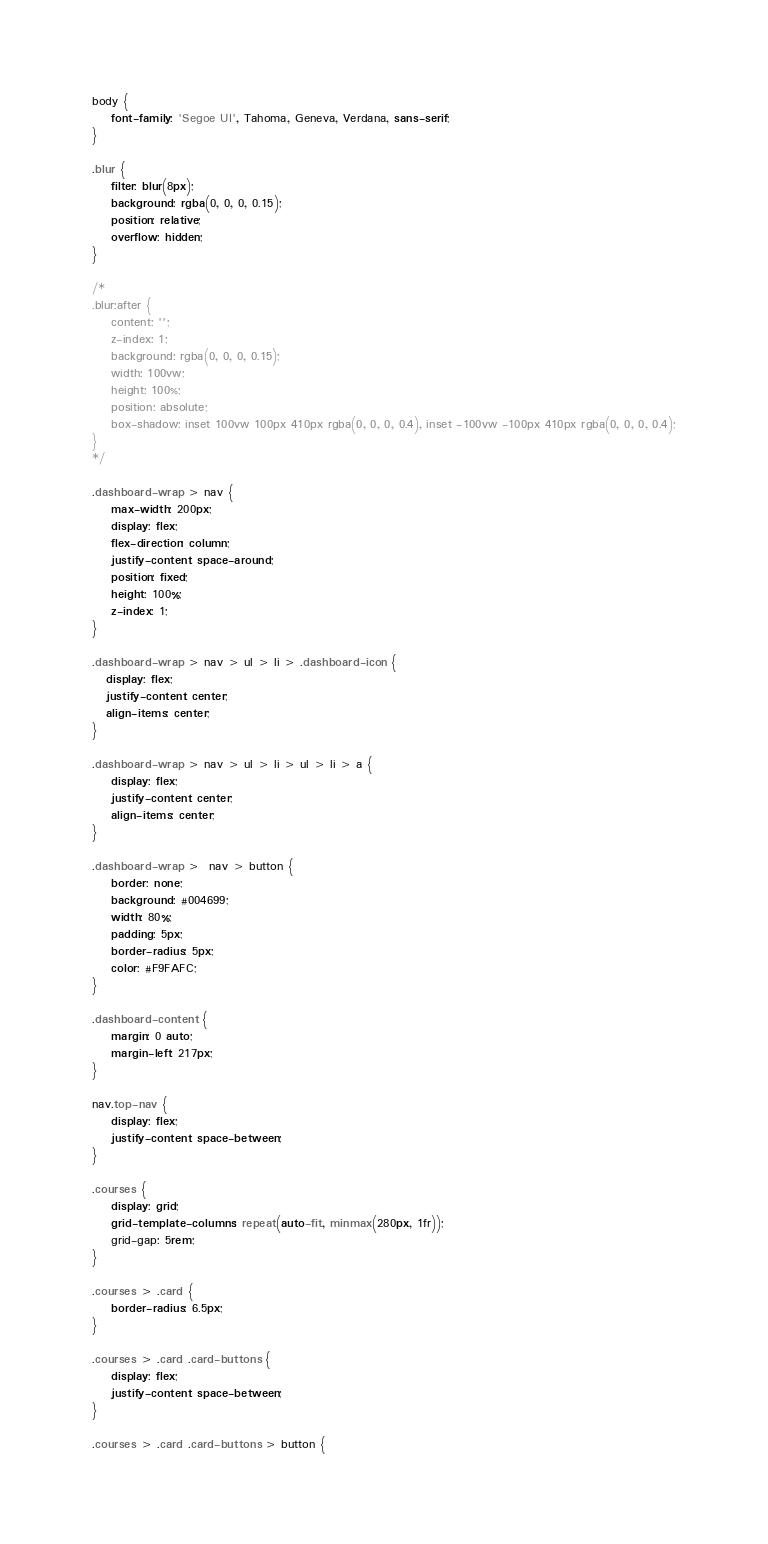<code> <loc_0><loc_0><loc_500><loc_500><_CSS_>body {
    font-family: 'Segoe UI', Tahoma, Geneva, Verdana, sans-serif;
}

.blur {
    filter: blur(8px);
    background: rgba(0, 0, 0, 0.15);
    position: relative;
    overflow: hidden;
}

/*
.blur:after {
    content: '';
    z-index: 1;
    background: rgba(0, 0, 0, 0.15);
    width: 100vw;
    height: 100%;
    position: absolute;
    box-shadow: inset 100vw 100px 410px rgba(0, 0, 0, 0.4), inset -100vw -100px 410px rgba(0, 0, 0, 0.4);
}
*/

.dashboard-wrap > nav {
    max-width: 200px;
    display: flex;
    flex-direction: column;
    justify-content: space-around;
    position: fixed;
    height: 100%;
    z-index: 1;
}

.dashboard-wrap > nav > ul > li > .dashboard-icon { 
   display: flex;
   justify-content: center;
   align-items: center;
}

.dashboard-wrap > nav > ul > li > ul > li > a { 
    display: flex;
    justify-content: center;
    align-items: center;
}

.dashboard-wrap >  nav > button {
    border: none;
    background: #004699;
    width: 80%;
    padding: 5px;
    border-radius: 5px;
    color: #F9FAFC;
}

.dashboard-content {
    margin: 0 auto;
    margin-left: 217px;
}

nav.top-nav {
    display: flex;
    justify-content: space-between;
}

.courses {
    display: grid;
    grid-template-columns: repeat(auto-fit, minmax(280px, 1fr));
    grid-gap: 5rem;
}

.courses > .card {
    border-radius: 6.5px;
}

.courses > .card .card-buttons {
    display: flex;
    justify-content: space-between;
}

.courses > .card .card-buttons > button {</code> 